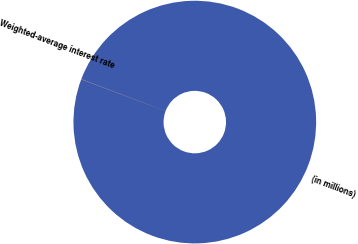Convert chart to OTSL. <chart><loc_0><loc_0><loc_500><loc_500><pie_chart><fcel>(in millions)<fcel>Weighted-average interest rate<nl><fcel>99.98%<fcel>0.02%<nl></chart> 